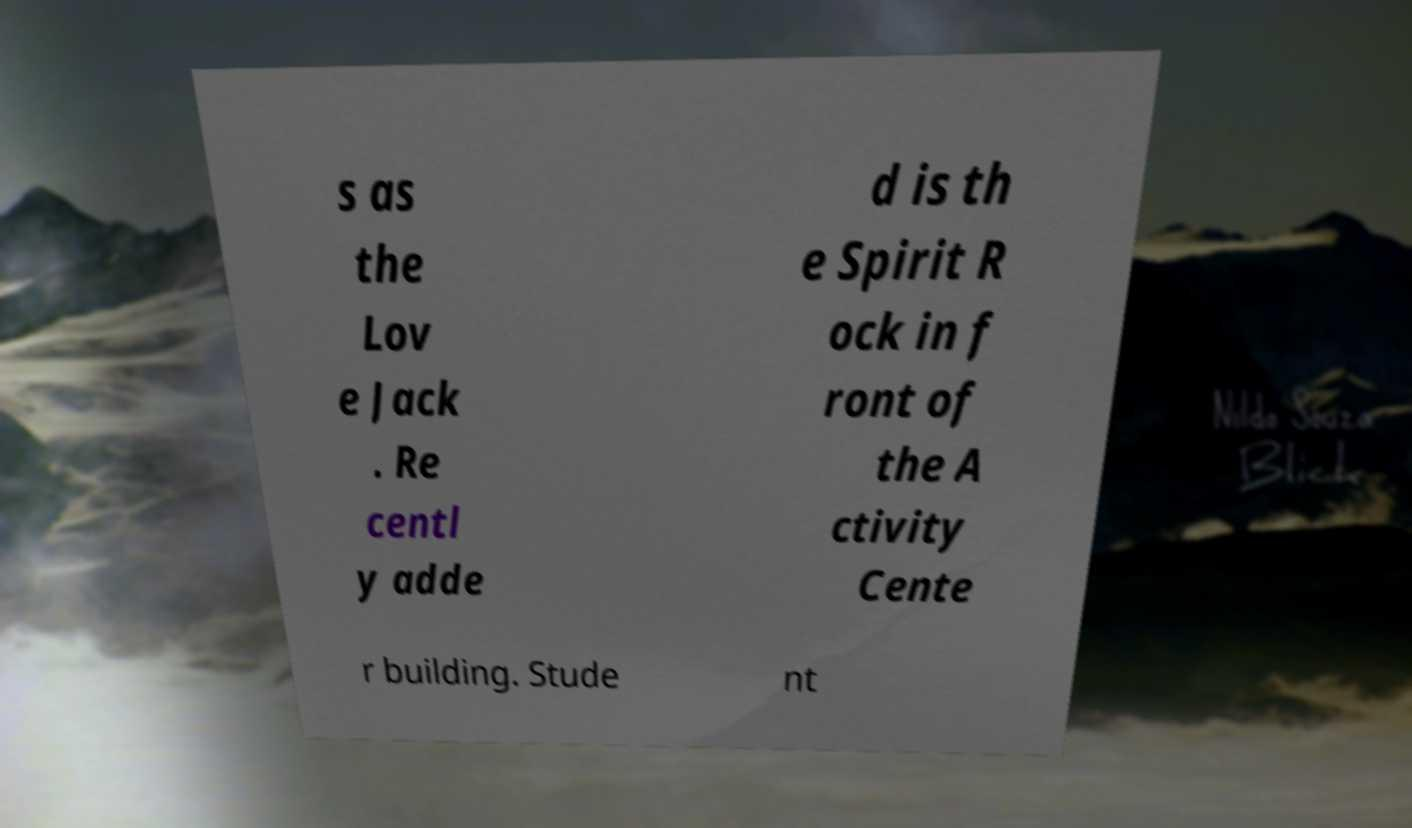Could you extract and type out the text from this image? s as the Lov e Jack . Re centl y adde d is th e Spirit R ock in f ront of the A ctivity Cente r building. Stude nt 